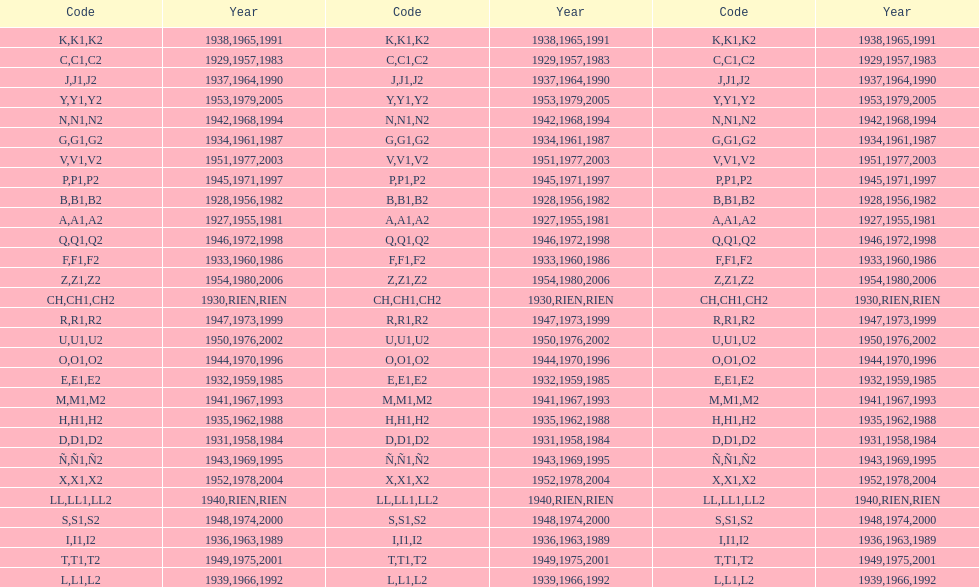How many different codes were used from 1953 to 1958? 6. 